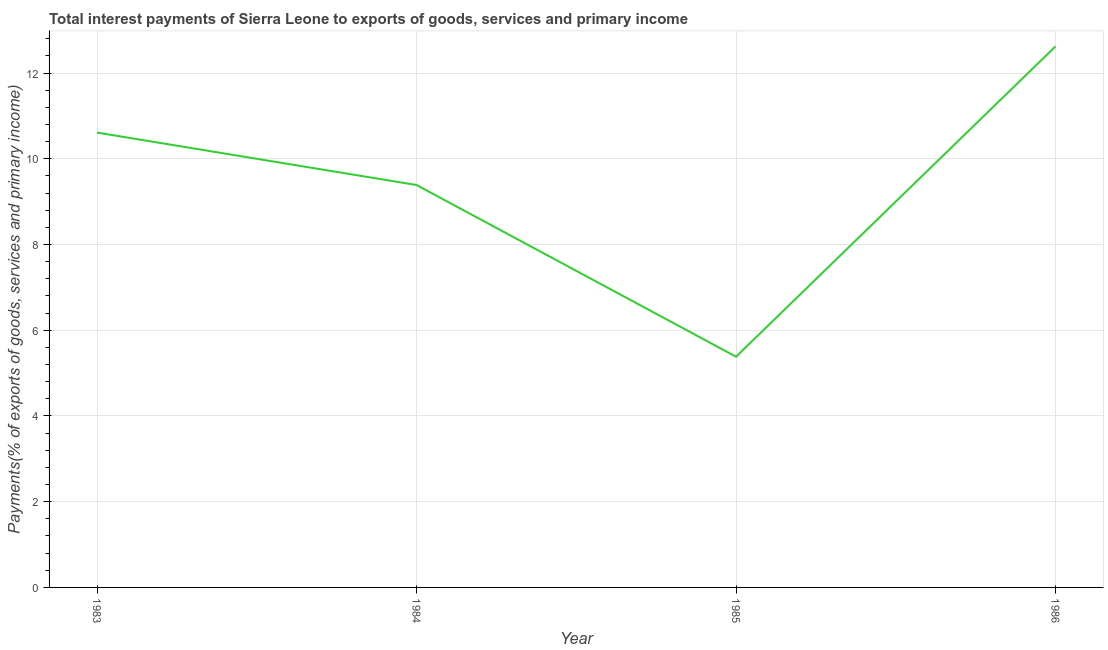What is the total interest payments on external debt in 1985?
Your answer should be very brief. 5.38. Across all years, what is the maximum total interest payments on external debt?
Provide a short and direct response. 12.62. Across all years, what is the minimum total interest payments on external debt?
Keep it short and to the point. 5.38. In which year was the total interest payments on external debt minimum?
Offer a terse response. 1985. What is the sum of the total interest payments on external debt?
Offer a terse response. 38.01. What is the difference between the total interest payments on external debt in 1983 and 1986?
Provide a short and direct response. -2.01. What is the average total interest payments on external debt per year?
Your response must be concise. 9.5. What is the median total interest payments on external debt?
Your answer should be very brief. 10. What is the ratio of the total interest payments on external debt in 1983 to that in 1986?
Provide a succinct answer. 0.84. Is the difference between the total interest payments on external debt in 1984 and 1986 greater than the difference between any two years?
Ensure brevity in your answer.  No. What is the difference between the highest and the second highest total interest payments on external debt?
Make the answer very short. 2.01. What is the difference between the highest and the lowest total interest payments on external debt?
Make the answer very short. 7.24. How many lines are there?
Offer a terse response. 1. How many years are there in the graph?
Offer a terse response. 4. Does the graph contain grids?
Make the answer very short. Yes. What is the title of the graph?
Offer a terse response. Total interest payments of Sierra Leone to exports of goods, services and primary income. What is the label or title of the X-axis?
Offer a very short reply. Year. What is the label or title of the Y-axis?
Offer a terse response. Payments(% of exports of goods, services and primary income). What is the Payments(% of exports of goods, services and primary income) in 1983?
Ensure brevity in your answer.  10.61. What is the Payments(% of exports of goods, services and primary income) of 1984?
Make the answer very short. 9.39. What is the Payments(% of exports of goods, services and primary income) of 1985?
Your answer should be compact. 5.38. What is the Payments(% of exports of goods, services and primary income) of 1986?
Your answer should be compact. 12.62. What is the difference between the Payments(% of exports of goods, services and primary income) in 1983 and 1984?
Provide a succinct answer. 1.22. What is the difference between the Payments(% of exports of goods, services and primary income) in 1983 and 1985?
Offer a terse response. 5.23. What is the difference between the Payments(% of exports of goods, services and primary income) in 1983 and 1986?
Give a very brief answer. -2.01. What is the difference between the Payments(% of exports of goods, services and primary income) in 1984 and 1985?
Offer a terse response. 4.01. What is the difference between the Payments(% of exports of goods, services and primary income) in 1984 and 1986?
Your answer should be compact. -3.24. What is the difference between the Payments(% of exports of goods, services and primary income) in 1985 and 1986?
Offer a terse response. -7.24. What is the ratio of the Payments(% of exports of goods, services and primary income) in 1983 to that in 1984?
Ensure brevity in your answer.  1.13. What is the ratio of the Payments(% of exports of goods, services and primary income) in 1983 to that in 1985?
Offer a terse response. 1.97. What is the ratio of the Payments(% of exports of goods, services and primary income) in 1983 to that in 1986?
Offer a terse response. 0.84. What is the ratio of the Payments(% of exports of goods, services and primary income) in 1984 to that in 1985?
Keep it short and to the point. 1.74. What is the ratio of the Payments(% of exports of goods, services and primary income) in 1984 to that in 1986?
Offer a very short reply. 0.74. What is the ratio of the Payments(% of exports of goods, services and primary income) in 1985 to that in 1986?
Offer a terse response. 0.43. 